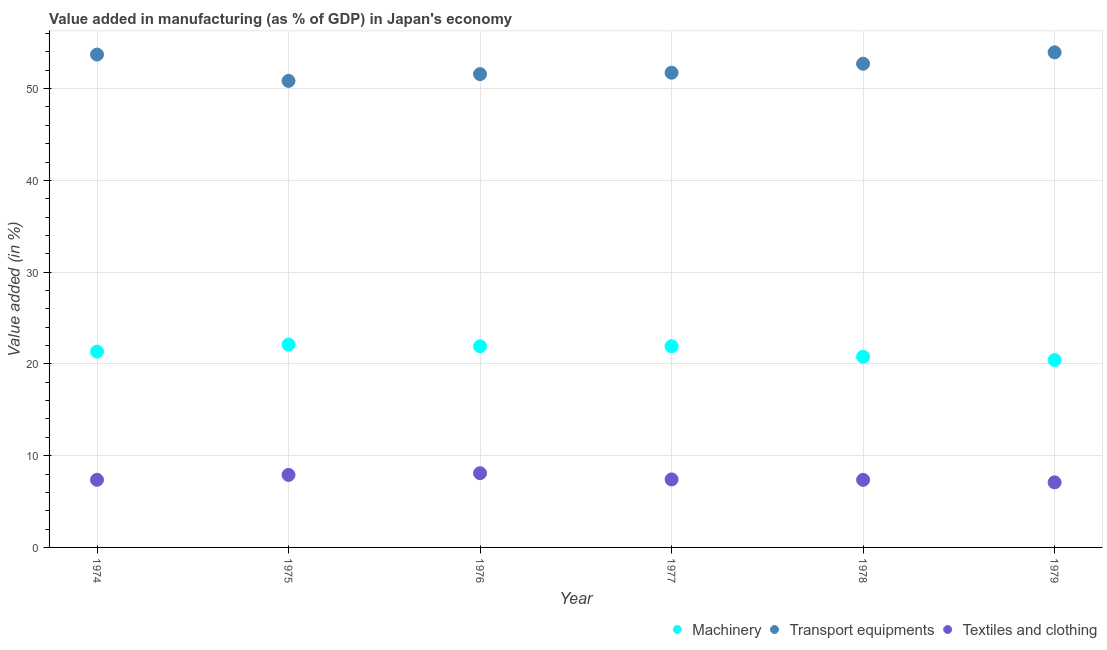How many different coloured dotlines are there?
Keep it short and to the point. 3. What is the value added in manufacturing transport equipments in 1974?
Offer a terse response. 53.71. Across all years, what is the maximum value added in manufacturing transport equipments?
Your answer should be compact. 53.95. Across all years, what is the minimum value added in manufacturing textile and clothing?
Your answer should be very brief. 7.09. In which year was the value added in manufacturing machinery maximum?
Provide a succinct answer. 1975. In which year was the value added in manufacturing transport equipments minimum?
Offer a terse response. 1975. What is the total value added in manufacturing textile and clothing in the graph?
Provide a succinct answer. 45.23. What is the difference between the value added in manufacturing machinery in 1975 and that in 1976?
Your response must be concise. 0.19. What is the difference between the value added in manufacturing transport equipments in 1975 and the value added in manufacturing textile and clothing in 1974?
Your response must be concise. 43.47. What is the average value added in manufacturing textile and clothing per year?
Offer a terse response. 7.54. In the year 1979, what is the difference between the value added in manufacturing textile and clothing and value added in manufacturing transport equipments?
Keep it short and to the point. -46.86. In how many years, is the value added in manufacturing transport equipments greater than 34 %?
Your response must be concise. 6. What is the ratio of the value added in manufacturing machinery in 1975 to that in 1978?
Your answer should be compact. 1.06. Is the value added in manufacturing machinery in 1974 less than that in 1979?
Offer a very short reply. No. What is the difference between the highest and the second highest value added in manufacturing transport equipments?
Your response must be concise. 0.24. What is the difference between the highest and the lowest value added in manufacturing machinery?
Offer a terse response. 1.69. In how many years, is the value added in manufacturing transport equipments greater than the average value added in manufacturing transport equipments taken over all years?
Your answer should be very brief. 3. Is the sum of the value added in manufacturing textile and clothing in 1974 and 1975 greater than the maximum value added in manufacturing machinery across all years?
Your answer should be very brief. No. How many dotlines are there?
Offer a very short reply. 3. How many years are there in the graph?
Your response must be concise. 6. What is the difference between two consecutive major ticks on the Y-axis?
Your answer should be very brief. 10. Does the graph contain grids?
Provide a succinct answer. Yes. Where does the legend appear in the graph?
Ensure brevity in your answer.  Bottom right. How are the legend labels stacked?
Your answer should be very brief. Horizontal. What is the title of the graph?
Your answer should be compact. Value added in manufacturing (as % of GDP) in Japan's economy. Does "Travel services" appear as one of the legend labels in the graph?
Make the answer very short. No. What is the label or title of the Y-axis?
Provide a succinct answer. Value added (in %). What is the Value added (in %) of Machinery in 1974?
Your answer should be very brief. 21.34. What is the Value added (in %) in Transport equipments in 1974?
Offer a very short reply. 53.71. What is the Value added (in %) in Textiles and clothing in 1974?
Your answer should be compact. 7.37. What is the Value added (in %) in Machinery in 1975?
Offer a very short reply. 22.11. What is the Value added (in %) of Transport equipments in 1975?
Provide a short and direct response. 50.84. What is the Value added (in %) in Textiles and clothing in 1975?
Keep it short and to the point. 7.9. What is the Value added (in %) in Machinery in 1976?
Your answer should be compact. 21.92. What is the Value added (in %) of Transport equipments in 1976?
Keep it short and to the point. 51.58. What is the Value added (in %) of Textiles and clothing in 1976?
Provide a succinct answer. 8.09. What is the Value added (in %) in Machinery in 1977?
Your answer should be compact. 21.92. What is the Value added (in %) in Transport equipments in 1977?
Provide a succinct answer. 51.73. What is the Value added (in %) in Textiles and clothing in 1977?
Your answer should be very brief. 7.41. What is the Value added (in %) in Machinery in 1978?
Provide a succinct answer. 20.78. What is the Value added (in %) of Transport equipments in 1978?
Offer a terse response. 52.71. What is the Value added (in %) in Textiles and clothing in 1978?
Ensure brevity in your answer.  7.36. What is the Value added (in %) of Machinery in 1979?
Ensure brevity in your answer.  20.42. What is the Value added (in %) in Transport equipments in 1979?
Provide a short and direct response. 53.95. What is the Value added (in %) of Textiles and clothing in 1979?
Make the answer very short. 7.09. Across all years, what is the maximum Value added (in %) in Machinery?
Offer a terse response. 22.11. Across all years, what is the maximum Value added (in %) of Transport equipments?
Give a very brief answer. 53.95. Across all years, what is the maximum Value added (in %) of Textiles and clothing?
Offer a very short reply. 8.09. Across all years, what is the minimum Value added (in %) of Machinery?
Offer a terse response. 20.42. Across all years, what is the minimum Value added (in %) of Transport equipments?
Your response must be concise. 50.84. Across all years, what is the minimum Value added (in %) of Textiles and clothing?
Give a very brief answer. 7.09. What is the total Value added (in %) of Machinery in the graph?
Keep it short and to the point. 128.49. What is the total Value added (in %) of Transport equipments in the graph?
Offer a very short reply. 314.51. What is the total Value added (in %) of Textiles and clothing in the graph?
Ensure brevity in your answer.  45.23. What is the difference between the Value added (in %) in Machinery in 1974 and that in 1975?
Ensure brevity in your answer.  -0.77. What is the difference between the Value added (in %) of Transport equipments in 1974 and that in 1975?
Your response must be concise. 2.87. What is the difference between the Value added (in %) in Textiles and clothing in 1974 and that in 1975?
Provide a short and direct response. -0.53. What is the difference between the Value added (in %) of Machinery in 1974 and that in 1976?
Offer a very short reply. -0.58. What is the difference between the Value added (in %) of Transport equipments in 1974 and that in 1976?
Keep it short and to the point. 2.13. What is the difference between the Value added (in %) of Textiles and clothing in 1974 and that in 1976?
Offer a very short reply. -0.72. What is the difference between the Value added (in %) of Machinery in 1974 and that in 1977?
Provide a succinct answer. -0.58. What is the difference between the Value added (in %) in Transport equipments in 1974 and that in 1977?
Provide a succinct answer. 1.98. What is the difference between the Value added (in %) in Textiles and clothing in 1974 and that in 1977?
Provide a succinct answer. -0.04. What is the difference between the Value added (in %) in Machinery in 1974 and that in 1978?
Your answer should be compact. 0.56. What is the difference between the Value added (in %) in Textiles and clothing in 1974 and that in 1978?
Keep it short and to the point. 0.01. What is the difference between the Value added (in %) in Machinery in 1974 and that in 1979?
Provide a succinct answer. 0.92. What is the difference between the Value added (in %) of Transport equipments in 1974 and that in 1979?
Provide a short and direct response. -0.24. What is the difference between the Value added (in %) of Textiles and clothing in 1974 and that in 1979?
Give a very brief answer. 0.28. What is the difference between the Value added (in %) in Machinery in 1975 and that in 1976?
Offer a terse response. 0.19. What is the difference between the Value added (in %) in Transport equipments in 1975 and that in 1976?
Offer a very short reply. -0.74. What is the difference between the Value added (in %) of Textiles and clothing in 1975 and that in 1976?
Offer a terse response. -0.19. What is the difference between the Value added (in %) of Machinery in 1975 and that in 1977?
Provide a short and direct response. 0.18. What is the difference between the Value added (in %) in Transport equipments in 1975 and that in 1977?
Ensure brevity in your answer.  -0.89. What is the difference between the Value added (in %) in Textiles and clothing in 1975 and that in 1977?
Your answer should be very brief. 0.49. What is the difference between the Value added (in %) of Machinery in 1975 and that in 1978?
Your answer should be compact. 1.33. What is the difference between the Value added (in %) of Transport equipments in 1975 and that in 1978?
Offer a very short reply. -1.87. What is the difference between the Value added (in %) in Textiles and clothing in 1975 and that in 1978?
Your response must be concise. 0.54. What is the difference between the Value added (in %) of Machinery in 1975 and that in 1979?
Provide a succinct answer. 1.69. What is the difference between the Value added (in %) in Transport equipments in 1975 and that in 1979?
Offer a very short reply. -3.11. What is the difference between the Value added (in %) of Textiles and clothing in 1975 and that in 1979?
Offer a very short reply. 0.81. What is the difference between the Value added (in %) of Machinery in 1976 and that in 1977?
Your answer should be very brief. -0. What is the difference between the Value added (in %) of Transport equipments in 1976 and that in 1977?
Provide a short and direct response. -0.15. What is the difference between the Value added (in %) in Textiles and clothing in 1976 and that in 1977?
Your response must be concise. 0.68. What is the difference between the Value added (in %) of Machinery in 1976 and that in 1978?
Provide a succinct answer. 1.14. What is the difference between the Value added (in %) of Transport equipments in 1976 and that in 1978?
Make the answer very short. -1.14. What is the difference between the Value added (in %) of Textiles and clothing in 1976 and that in 1978?
Your answer should be very brief. 0.73. What is the difference between the Value added (in %) of Machinery in 1976 and that in 1979?
Provide a short and direct response. 1.5. What is the difference between the Value added (in %) in Transport equipments in 1976 and that in 1979?
Provide a short and direct response. -2.38. What is the difference between the Value added (in %) of Machinery in 1977 and that in 1978?
Make the answer very short. 1.14. What is the difference between the Value added (in %) in Transport equipments in 1977 and that in 1978?
Your response must be concise. -0.98. What is the difference between the Value added (in %) of Textiles and clothing in 1977 and that in 1978?
Ensure brevity in your answer.  0.05. What is the difference between the Value added (in %) in Machinery in 1977 and that in 1979?
Offer a terse response. 1.5. What is the difference between the Value added (in %) of Transport equipments in 1977 and that in 1979?
Make the answer very short. -2.22. What is the difference between the Value added (in %) in Textiles and clothing in 1977 and that in 1979?
Give a very brief answer. 0.32. What is the difference between the Value added (in %) of Machinery in 1978 and that in 1979?
Make the answer very short. 0.36. What is the difference between the Value added (in %) in Transport equipments in 1978 and that in 1979?
Provide a short and direct response. -1.24. What is the difference between the Value added (in %) in Textiles and clothing in 1978 and that in 1979?
Your response must be concise. 0.27. What is the difference between the Value added (in %) of Machinery in 1974 and the Value added (in %) of Transport equipments in 1975?
Give a very brief answer. -29.5. What is the difference between the Value added (in %) in Machinery in 1974 and the Value added (in %) in Textiles and clothing in 1975?
Make the answer very short. 13.44. What is the difference between the Value added (in %) in Transport equipments in 1974 and the Value added (in %) in Textiles and clothing in 1975?
Provide a short and direct response. 45.81. What is the difference between the Value added (in %) in Machinery in 1974 and the Value added (in %) in Transport equipments in 1976?
Your answer should be compact. -30.24. What is the difference between the Value added (in %) of Machinery in 1974 and the Value added (in %) of Textiles and clothing in 1976?
Make the answer very short. 13.25. What is the difference between the Value added (in %) of Transport equipments in 1974 and the Value added (in %) of Textiles and clothing in 1976?
Keep it short and to the point. 45.62. What is the difference between the Value added (in %) of Machinery in 1974 and the Value added (in %) of Transport equipments in 1977?
Make the answer very short. -30.39. What is the difference between the Value added (in %) in Machinery in 1974 and the Value added (in %) in Textiles and clothing in 1977?
Keep it short and to the point. 13.93. What is the difference between the Value added (in %) of Transport equipments in 1974 and the Value added (in %) of Textiles and clothing in 1977?
Keep it short and to the point. 46.3. What is the difference between the Value added (in %) in Machinery in 1974 and the Value added (in %) in Transport equipments in 1978?
Offer a very short reply. -31.37. What is the difference between the Value added (in %) of Machinery in 1974 and the Value added (in %) of Textiles and clothing in 1978?
Ensure brevity in your answer.  13.98. What is the difference between the Value added (in %) in Transport equipments in 1974 and the Value added (in %) in Textiles and clothing in 1978?
Offer a very short reply. 46.34. What is the difference between the Value added (in %) of Machinery in 1974 and the Value added (in %) of Transport equipments in 1979?
Keep it short and to the point. -32.61. What is the difference between the Value added (in %) in Machinery in 1974 and the Value added (in %) in Textiles and clothing in 1979?
Ensure brevity in your answer.  14.25. What is the difference between the Value added (in %) in Transport equipments in 1974 and the Value added (in %) in Textiles and clothing in 1979?
Ensure brevity in your answer.  46.61. What is the difference between the Value added (in %) of Machinery in 1975 and the Value added (in %) of Transport equipments in 1976?
Give a very brief answer. -29.47. What is the difference between the Value added (in %) of Machinery in 1975 and the Value added (in %) of Textiles and clothing in 1976?
Offer a very short reply. 14.02. What is the difference between the Value added (in %) of Transport equipments in 1975 and the Value added (in %) of Textiles and clothing in 1976?
Keep it short and to the point. 42.75. What is the difference between the Value added (in %) of Machinery in 1975 and the Value added (in %) of Transport equipments in 1977?
Your response must be concise. -29.62. What is the difference between the Value added (in %) in Machinery in 1975 and the Value added (in %) in Textiles and clothing in 1977?
Give a very brief answer. 14.69. What is the difference between the Value added (in %) of Transport equipments in 1975 and the Value added (in %) of Textiles and clothing in 1977?
Offer a very short reply. 43.42. What is the difference between the Value added (in %) of Machinery in 1975 and the Value added (in %) of Transport equipments in 1978?
Your answer should be compact. -30.61. What is the difference between the Value added (in %) in Machinery in 1975 and the Value added (in %) in Textiles and clothing in 1978?
Give a very brief answer. 14.74. What is the difference between the Value added (in %) in Transport equipments in 1975 and the Value added (in %) in Textiles and clothing in 1978?
Your response must be concise. 43.47. What is the difference between the Value added (in %) of Machinery in 1975 and the Value added (in %) of Transport equipments in 1979?
Your response must be concise. -31.85. What is the difference between the Value added (in %) in Machinery in 1975 and the Value added (in %) in Textiles and clothing in 1979?
Ensure brevity in your answer.  15.01. What is the difference between the Value added (in %) in Transport equipments in 1975 and the Value added (in %) in Textiles and clothing in 1979?
Give a very brief answer. 43.74. What is the difference between the Value added (in %) of Machinery in 1976 and the Value added (in %) of Transport equipments in 1977?
Your answer should be compact. -29.81. What is the difference between the Value added (in %) of Machinery in 1976 and the Value added (in %) of Textiles and clothing in 1977?
Offer a terse response. 14.51. What is the difference between the Value added (in %) in Transport equipments in 1976 and the Value added (in %) in Textiles and clothing in 1977?
Give a very brief answer. 44.16. What is the difference between the Value added (in %) in Machinery in 1976 and the Value added (in %) in Transport equipments in 1978?
Your response must be concise. -30.79. What is the difference between the Value added (in %) in Machinery in 1976 and the Value added (in %) in Textiles and clothing in 1978?
Offer a terse response. 14.56. What is the difference between the Value added (in %) of Transport equipments in 1976 and the Value added (in %) of Textiles and clothing in 1978?
Your response must be concise. 44.21. What is the difference between the Value added (in %) in Machinery in 1976 and the Value added (in %) in Transport equipments in 1979?
Offer a very short reply. -32.03. What is the difference between the Value added (in %) in Machinery in 1976 and the Value added (in %) in Textiles and clothing in 1979?
Provide a short and direct response. 14.83. What is the difference between the Value added (in %) in Transport equipments in 1976 and the Value added (in %) in Textiles and clothing in 1979?
Ensure brevity in your answer.  44.48. What is the difference between the Value added (in %) of Machinery in 1977 and the Value added (in %) of Transport equipments in 1978?
Your answer should be very brief. -30.79. What is the difference between the Value added (in %) of Machinery in 1977 and the Value added (in %) of Textiles and clothing in 1978?
Make the answer very short. 14.56. What is the difference between the Value added (in %) of Transport equipments in 1977 and the Value added (in %) of Textiles and clothing in 1978?
Ensure brevity in your answer.  44.37. What is the difference between the Value added (in %) of Machinery in 1977 and the Value added (in %) of Transport equipments in 1979?
Keep it short and to the point. -32.03. What is the difference between the Value added (in %) of Machinery in 1977 and the Value added (in %) of Textiles and clothing in 1979?
Offer a terse response. 14.83. What is the difference between the Value added (in %) in Transport equipments in 1977 and the Value added (in %) in Textiles and clothing in 1979?
Give a very brief answer. 44.64. What is the difference between the Value added (in %) of Machinery in 1978 and the Value added (in %) of Transport equipments in 1979?
Give a very brief answer. -33.17. What is the difference between the Value added (in %) of Machinery in 1978 and the Value added (in %) of Textiles and clothing in 1979?
Your answer should be very brief. 13.69. What is the difference between the Value added (in %) in Transport equipments in 1978 and the Value added (in %) in Textiles and clothing in 1979?
Provide a short and direct response. 45.62. What is the average Value added (in %) in Machinery per year?
Make the answer very short. 21.42. What is the average Value added (in %) of Transport equipments per year?
Give a very brief answer. 52.42. What is the average Value added (in %) in Textiles and clothing per year?
Give a very brief answer. 7.54. In the year 1974, what is the difference between the Value added (in %) of Machinery and Value added (in %) of Transport equipments?
Ensure brevity in your answer.  -32.37. In the year 1974, what is the difference between the Value added (in %) in Machinery and Value added (in %) in Textiles and clothing?
Your answer should be compact. 13.97. In the year 1974, what is the difference between the Value added (in %) in Transport equipments and Value added (in %) in Textiles and clothing?
Keep it short and to the point. 46.34. In the year 1975, what is the difference between the Value added (in %) of Machinery and Value added (in %) of Transport equipments?
Offer a very short reply. -28.73. In the year 1975, what is the difference between the Value added (in %) of Machinery and Value added (in %) of Textiles and clothing?
Provide a succinct answer. 14.2. In the year 1975, what is the difference between the Value added (in %) in Transport equipments and Value added (in %) in Textiles and clothing?
Make the answer very short. 42.93. In the year 1976, what is the difference between the Value added (in %) of Machinery and Value added (in %) of Transport equipments?
Give a very brief answer. -29.66. In the year 1976, what is the difference between the Value added (in %) in Machinery and Value added (in %) in Textiles and clothing?
Offer a very short reply. 13.83. In the year 1976, what is the difference between the Value added (in %) of Transport equipments and Value added (in %) of Textiles and clothing?
Make the answer very short. 43.49. In the year 1977, what is the difference between the Value added (in %) of Machinery and Value added (in %) of Transport equipments?
Make the answer very short. -29.81. In the year 1977, what is the difference between the Value added (in %) in Machinery and Value added (in %) in Textiles and clothing?
Make the answer very short. 14.51. In the year 1977, what is the difference between the Value added (in %) of Transport equipments and Value added (in %) of Textiles and clothing?
Your answer should be very brief. 44.32. In the year 1978, what is the difference between the Value added (in %) of Machinery and Value added (in %) of Transport equipments?
Keep it short and to the point. -31.93. In the year 1978, what is the difference between the Value added (in %) in Machinery and Value added (in %) in Textiles and clothing?
Your answer should be very brief. 13.42. In the year 1978, what is the difference between the Value added (in %) of Transport equipments and Value added (in %) of Textiles and clothing?
Make the answer very short. 45.35. In the year 1979, what is the difference between the Value added (in %) of Machinery and Value added (in %) of Transport equipments?
Keep it short and to the point. -33.53. In the year 1979, what is the difference between the Value added (in %) of Machinery and Value added (in %) of Textiles and clothing?
Ensure brevity in your answer.  13.33. In the year 1979, what is the difference between the Value added (in %) in Transport equipments and Value added (in %) in Textiles and clothing?
Offer a terse response. 46.86. What is the ratio of the Value added (in %) of Machinery in 1974 to that in 1975?
Offer a very short reply. 0.97. What is the ratio of the Value added (in %) of Transport equipments in 1974 to that in 1975?
Keep it short and to the point. 1.06. What is the ratio of the Value added (in %) of Textiles and clothing in 1974 to that in 1975?
Keep it short and to the point. 0.93. What is the ratio of the Value added (in %) in Machinery in 1974 to that in 1976?
Offer a terse response. 0.97. What is the ratio of the Value added (in %) in Transport equipments in 1974 to that in 1976?
Provide a short and direct response. 1.04. What is the ratio of the Value added (in %) of Textiles and clothing in 1974 to that in 1976?
Your response must be concise. 0.91. What is the ratio of the Value added (in %) of Machinery in 1974 to that in 1977?
Keep it short and to the point. 0.97. What is the ratio of the Value added (in %) in Transport equipments in 1974 to that in 1977?
Offer a terse response. 1.04. What is the ratio of the Value added (in %) of Machinery in 1974 to that in 1978?
Provide a succinct answer. 1.03. What is the ratio of the Value added (in %) in Transport equipments in 1974 to that in 1978?
Ensure brevity in your answer.  1.02. What is the ratio of the Value added (in %) of Textiles and clothing in 1974 to that in 1978?
Give a very brief answer. 1. What is the ratio of the Value added (in %) in Machinery in 1974 to that in 1979?
Offer a terse response. 1.04. What is the ratio of the Value added (in %) of Textiles and clothing in 1974 to that in 1979?
Keep it short and to the point. 1.04. What is the ratio of the Value added (in %) in Machinery in 1975 to that in 1976?
Provide a short and direct response. 1.01. What is the ratio of the Value added (in %) in Transport equipments in 1975 to that in 1976?
Provide a succinct answer. 0.99. What is the ratio of the Value added (in %) in Textiles and clothing in 1975 to that in 1976?
Provide a succinct answer. 0.98. What is the ratio of the Value added (in %) in Machinery in 1975 to that in 1977?
Make the answer very short. 1.01. What is the ratio of the Value added (in %) in Transport equipments in 1975 to that in 1977?
Offer a terse response. 0.98. What is the ratio of the Value added (in %) of Textiles and clothing in 1975 to that in 1977?
Make the answer very short. 1.07. What is the ratio of the Value added (in %) of Machinery in 1975 to that in 1978?
Provide a succinct answer. 1.06. What is the ratio of the Value added (in %) in Transport equipments in 1975 to that in 1978?
Keep it short and to the point. 0.96. What is the ratio of the Value added (in %) in Textiles and clothing in 1975 to that in 1978?
Give a very brief answer. 1.07. What is the ratio of the Value added (in %) in Machinery in 1975 to that in 1979?
Offer a terse response. 1.08. What is the ratio of the Value added (in %) in Transport equipments in 1975 to that in 1979?
Offer a very short reply. 0.94. What is the ratio of the Value added (in %) in Textiles and clothing in 1975 to that in 1979?
Your answer should be very brief. 1.11. What is the ratio of the Value added (in %) in Transport equipments in 1976 to that in 1977?
Ensure brevity in your answer.  1. What is the ratio of the Value added (in %) in Textiles and clothing in 1976 to that in 1977?
Offer a very short reply. 1.09. What is the ratio of the Value added (in %) in Machinery in 1976 to that in 1978?
Make the answer very short. 1.05. What is the ratio of the Value added (in %) of Transport equipments in 1976 to that in 1978?
Keep it short and to the point. 0.98. What is the ratio of the Value added (in %) of Textiles and clothing in 1976 to that in 1978?
Provide a succinct answer. 1.1. What is the ratio of the Value added (in %) in Machinery in 1976 to that in 1979?
Make the answer very short. 1.07. What is the ratio of the Value added (in %) of Transport equipments in 1976 to that in 1979?
Make the answer very short. 0.96. What is the ratio of the Value added (in %) of Textiles and clothing in 1976 to that in 1979?
Provide a succinct answer. 1.14. What is the ratio of the Value added (in %) in Machinery in 1977 to that in 1978?
Your answer should be very brief. 1.06. What is the ratio of the Value added (in %) in Transport equipments in 1977 to that in 1978?
Make the answer very short. 0.98. What is the ratio of the Value added (in %) of Textiles and clothing in 1977 to that in 1978?
Ensure brevity in your answer.  1.01. What is the ratio of the Value added (in %) of Machinery in 1977 to that in 1979?
Offer a terse response. 1.07. What is the ratio of the Value added (in %) of Transport equipments in 1977 to that in 1979?
Keep it short and to the point. 0.96. What is the ratio of the Value added (in %) of Textiles and clothing in 1977 to that in 1979?
Your answer should be very brief. 1.04. What is the ratio of the Value added (in %) in Machinery in 1978 to that in 1979?
Your answer should be very brief. 1.02. What is the ratio of the Value added (in %) in Textiles and clothing in 1978 to that in 1979?
Provide a succinct answer. 1.04. What is the difference between the highest and the second highest Value added (in %) in Machinery?
Your answer should be compact. 0.18. What is the difference between the highest and the second highest Value added (in %) in Transport equipments?
Your answer should be very brief. 0.24. What is the difference between the highest and the second highest Value added (in %) of Textiles and clothing?
Offer a very short reply. 0.19. What is the difference between the highest and the lowest Value added (in %) in Machinery?
Keep it short and to the point. 1.69. What is the difference between the highest and the lowest Value added (in %) of Transport equipments?
Ensure brevity in your answer.  3.11. 